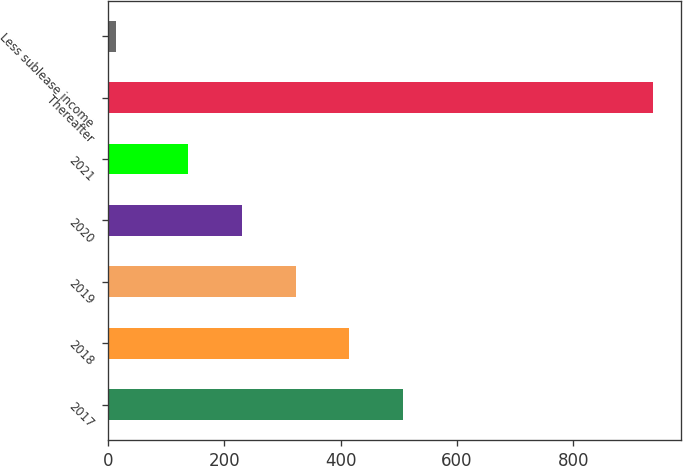Convert chart to OTSL. <chart><loc_0><loc_0><loc_500><loc_500><bar_chart><fcel>2017<fcel>2018<fcel>2019<fcel>2020<fcel>2021<fcel>Thereafter<fcel>Less sublease income<nl><fcel>507.6<fcel>415.2<fcel>322.8<fcel>230.4<fcel>138<fcel>938<fcel>14<nl></chart> 